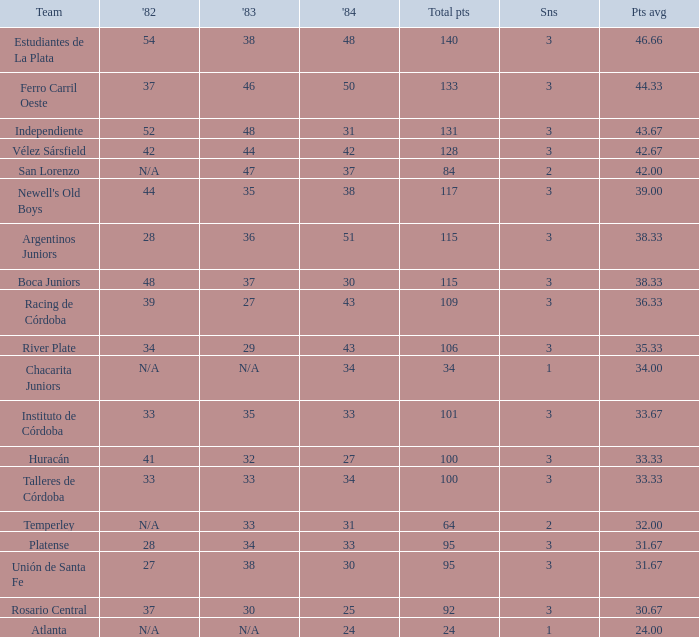What is the total for 1984 for the team with 100 points total and more than 3 seasons? None. 